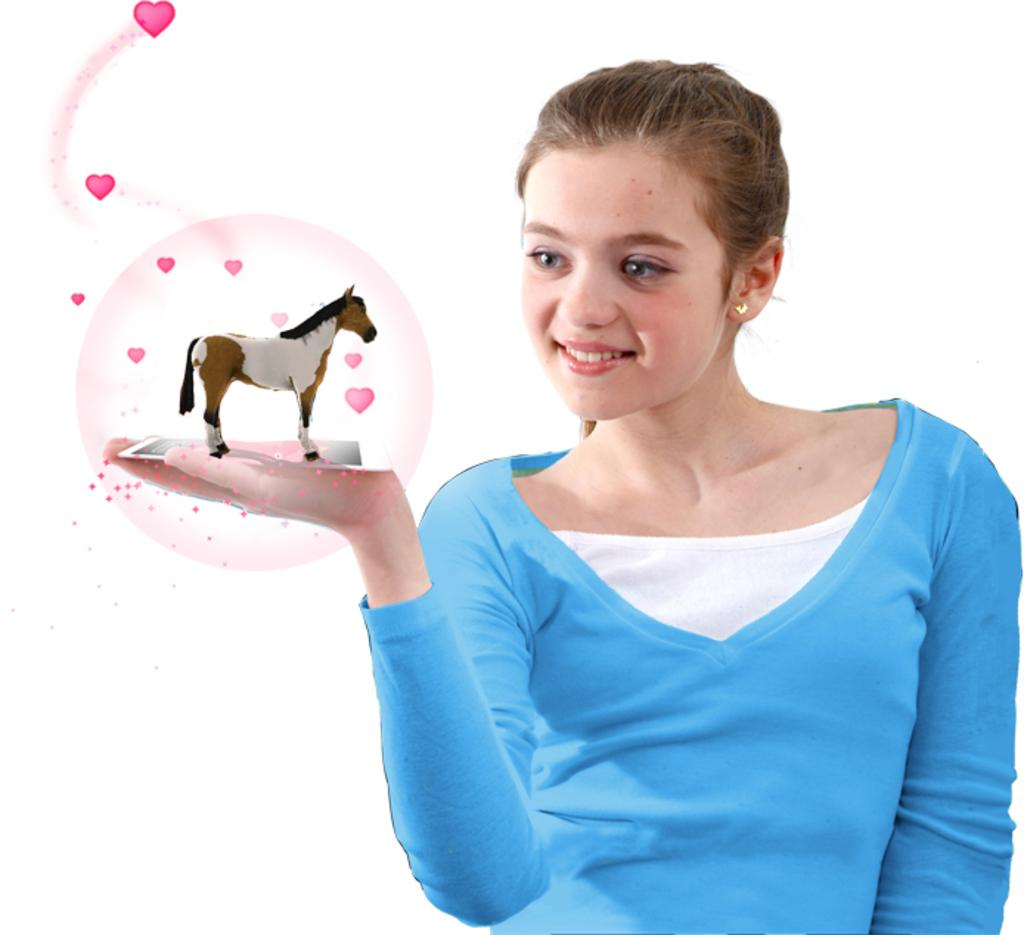Who is the main subject in the image? There is a girl in the image. What is the girl holding in the image? The girl is holding a horse toy. What is the girl's facial expression in the image? The girl has a smile on her face. What color is the background of the image? The background of the image is white. What type of owl can be seen in the image? There is no owl present in the image; it features a girl holding a horse toy. What subject is the girl learning about in the image? The image does not depict the girl learning about any specific subject. 